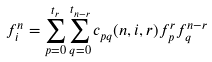Convert formula to latex. <formula><loc_0><loc_0><loc_500><loc_500>f ^ { n } _ { i } = \sum _ { p = 0 } ^ { t _ { r } } \sum _ { q = 0 } ^ { t _ { n - r } } c _ { p q } ( n , i , r ) f ^ { r } _ { p } f ^ { n - r } _ { q }</formula> 